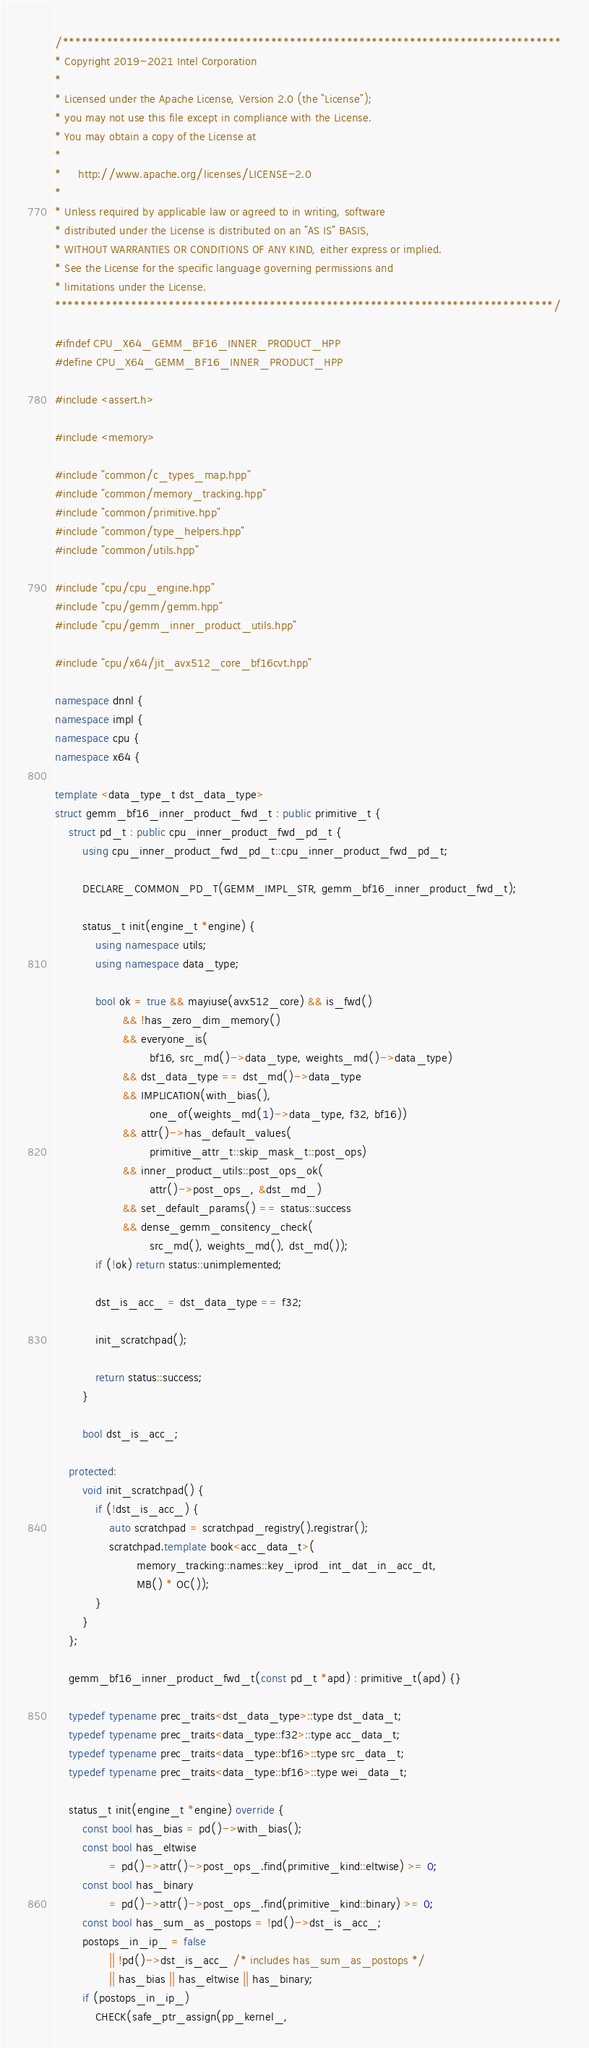<code> <loc_0><loc_0><loc_500><loc_500><_C++_>/*******************************************************************************
* Copyright 2019-2021 Intel Corporation
*
* Licensed under the Apache License, Version 2.0 (the "License");
* you may not use this file except in compliance with the License.
* You may obtain a copy of the License at
*
*     http://www.apache.org/licenses/LICENSE-2.0
*
* Unless required by applicable law or agreed to in writing, software
* distributed under the License is distributed on an "AS IS" BASIS,
* WITHOUT WARRANTIES OR CONDITIONS OF ANY KIND, either express or implied.
* See the License for the specific language governing permissions and
* limitations under the License.
*******************************************************************************/

#ifndef CPU_X64_GEMM_BF16_INNER_PRODUCT_HPP
#define CPU_X64_GEMM_BF16_INNER_PRODUCT_HPP

#include <assert.h>

#include <memory>

#include "common/c_types_map.hpp"
#include "common/memory_tracking.hpp"
#include "common/primitive.hpp"
#include "common/type_helpers.hpp"
#include "common/utils.hpp"

#include "cpu/cpu_engine.hpp"
#include "cpu/gemm/gemm.hpp"
#include "cpu/gemm_inner_product_utils.hpp"

#include "cpu/x64/jit_avx512_core_bf16cvt.hpp"

namespace dnnl {
namespace impl {
namespace cpu {
namespace x64 {

template <data_type_t dst_data_type>
struct gemm_bf16_inner_product_fwd_t : public primitive_t {
    struct pd_t : public cpu_inner_product_fwd_pd_t {
        using cpu_inner_product_fwd_pd_t::cpu_inner_product_fwd_pd_t;

        DECLARE_COMMON_PD_T(GEMM_IMPL_STR, gemm_bf16_inner_product_fwd_t);

        status_t init(engine_t *engine) {
            using namespace utils;
            using namespace data_type;

            bool ok = true && mayiuse(avx512_core) && is_fwd()
                    && !has_zero_dim_memory()
                    && everyone_is(
                            bf16, src_md()->data_type, weights_md()->data_type)
                    && dst_data_type == dst_md()->data_type
                    && IMPLICATION(with_bias(),
                            one_of(weights_md(1)->data_type, f32, bf16))
                    && attr()->has_default_values(
                            primitive_attr_t::skip_mask_t::post_ops)
                    && inner_product_utils::post_ops_ok(
                            attr()->post_ops_, &dst_md_)
                    && set_default_params() == status::success
                    && dense_gemm_consitency_check(
                            src_md(), weights_md(), dst_md());
            if (!ok) return status::unimplemented;

            dst_is_acc_ = dst_data_type == f32;

            init_scratchpad();

            return status::success;
        }

        bool dst_is_acc_;

    protected:
        void init_scratchpad() {
            if (!dst_is_acc_) {
                auto scratchpad = scratchpad_registry().registrar();
                scratchpad.template book<acc_data_t>(
                        memory_tracking::names::key_iprod_int_dat_in_acc_dt,
                        MB() * OC());
            }
        }
    };

    gemm_bf16_inner_product_fwd_t(const pd_t *apd) : primitive_t(apd) {}

    typedef typename prec_traits<dst_data_type>::type dst_data_t;
    typedef typename prec_traits<data_type::f32>::type acc_data_t;
    typedef typename prec_traits<data_type::bf16>::type src_data_t;
    typedef typename prec_traits<data_type::bf16>::type wei_data_t;

    status_t init(engine_t *engine) override {
        const bool has_bias = pd()->with_bias();
        const bool has_eltwise
                = pd()->attr()->post_ops_.find(primitive_kind::eltwise) >= 0;
        const bool has_binary
                = pd()->attr()->post_ops_.find(primitive_kind::binary) >= 0;
        const bool has_sum_as_postops = !pd()->dst_is_acc_;
        postops_in_ip_ = false
                || !pd()->dst_is_acc_ /* includes has_sum_as_postops */
                || has_bias || has_eltwise || has_binary;
        if (postops_in_ip_)
            CHECK(safe_ptr_assign(pp_kernel_,</code> 